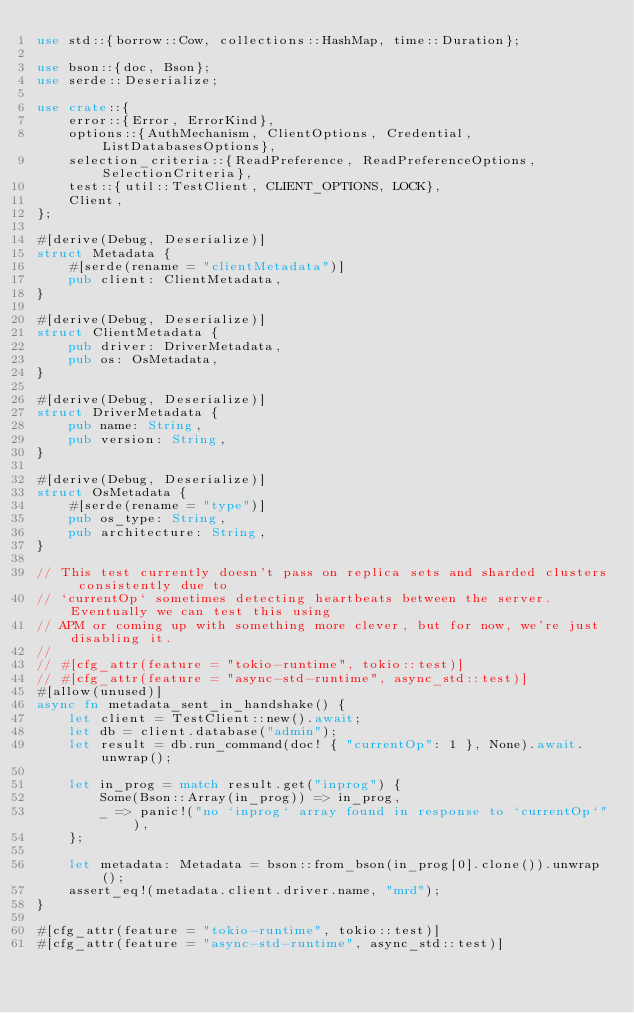<code> <loc_0><loc_0><loc_500><loc_500><_Rust_>use std::{borrow::Cow, collections::HashMap, time::Duration};

use bson::{doc, Bson};
use serde::Deserialize;

use crate::{
    error::{Error, ErrorKind},
    options::{AuthMechanism, ClientOptions, Credential, ListDatabasesOptions},
    selection_criteria::{ReadPreference, ReadPreferenceOptions, SelectionCriteria},
    test::{util::TestClient, CLIENT_OPTIONS, LOCK},
    Client,
};

#[derive(Debug, Deserialize)]
struct Metadata {
    #[serde(rename = "clientMetadata")]
    pub client: ClientMetadata,
}

#[derive(Debug, Deserialize)]
struct ClientMetadata {
    pub driver: DriverMetadata,
    pub os: OsMetadata,
}

#[derive(Debug, Deserialize)]
struct DriverMetadata {
    pub name: String,
    pub version: String,
}

#[derive(Debug, Deserialize)]
struct OsMetadata {
    #[serde(rename = "type")]
    pub os_type: String,
    pub architecture: String,
}

// This test currently doesn't pass on replica sets and sharded clusters consistently due to
// `currentOp` sometimes detecting heartbeats between the server. Eventually we can test this using
// APM or coming up with something more clever, but for now, we're just disabling it.
//
// #[cfg_attr(feature = "tokio-runtime", tokio::test)]
// #[cfg_attr(feature = "async-std-runtime", async_std::test)]
#[allow(unused)]
async fn metadata_sent_in_handshake() {
    let client = TestClient::new().await;
    let db = client.database("admin");
    let result = db.run_command(doc! { "currentOp": 1 }, None).await.unwrap();

    let in_prog = match result.get("inprog") {
        Some(Bson::Array(in_prog)) => in_prog,
        _ => panic!("no `inprog` array found in response to `currentOp`"),
    };

    let metadata: Metadata = bson::from_bson(in_prog[0].clone()).unwrap();
    assert_eq!(metadata.client.driver.name, "mrd");
}

#[cfg_attr(feature = "tokio-runtime", tokio::test)]
#[cfg_attr(feature = "async-std-runtime", async_std::test)]</code> 